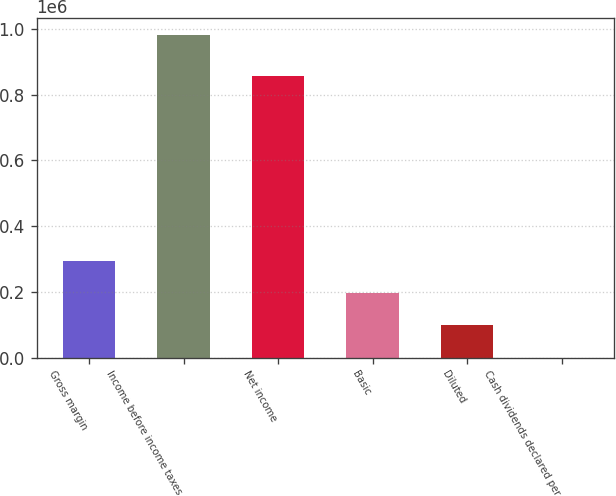<chart> <loc_0><loc_0><loc_500><loc_500><bar_chart><fcel>Gross margin<fcel>Income before income taxes<fcel>Net income<fcel>Basic<fcel>Diluted<fcel>Cash dividends declared per<nl><fcel>294763<fcel>982542<fcel>855984<fcel>196508<fcel>98254.3<fcel>0.07<nl></chart> 